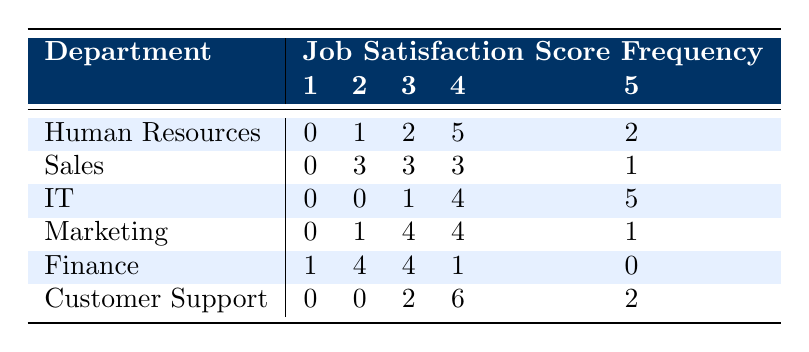What is the highest job satisfaction score reported in the IT department? In the row for the IT department, the highest score listed is 5, and it occurs five times.
Answer: 5 How many employees from the Sales department rated their job satisfaction as 2? The Sales department's row shows that the frequency for the score of 2 is 3.
Answer: 3 Is there any department where all job satisfaction scores of 1 are equal to zero? Yes, all scores of 1 for IT, Human Resources, Marketing, and Customer Support are zero.
Answer: Yes What is the total number of employees who rated their job satisfaction as 4 in the Customer Support department? From the Customer Support row, the frequency for the score of 4 is 6.
Answer: 6 Which department has the highest frequency of job satisfaction score equal to 3? The Marketing department has the highest frequency of score 3, which is 4.
Answer: Marketing Calculate the average job satisfaction score for the Finance department. The scores for Finance are 2, 3, 2, 3, 1, 2, 3, 2, 4, 3. Their sum is 25, and with 10 data points the average is 25/10 = 2.5.
Answer: 2.5 Which department has the lowest total number of scores for 5? The Finance department has a total of 0 occurrences for the score of 5, which is the lowest.
Answer: Finance Among all departments, how many employees rated their job satisfaction as 2? The total score for 2 is obtained by adding the frequencies for that score across departments: 1 (HR) + 3 (Sales) + 0 (IT) + 1 (Marketing) + 4 (Finance) + 0 (CS) = 9.
Answer: 9 Which department has the highest score frequency for the score of 3? The department with the highest frequency for the score of 3 is Sales with a frequency of 3, but Marketing has a score of 4.
Answer: Marketing 